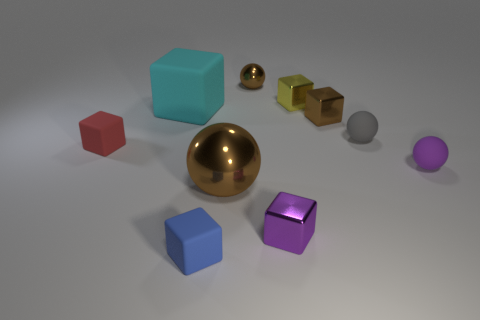Is the size of the brown shiny thing that is behind the brown cube the same as the brown block?
Provide a short and direct response. Yes. There is a tiny object that is on the left side of the cyan matte object; what is its material?
Offer a very short reply. Rubber. What number of rubber things are brown blocks or purple balls?
Your response must be concise. 1. Are there fewer gray spheres to the left of the tiny gray thing than big brown cubes?
Offer a terse response. No. What is the shape of the tiny brown shiny thing in front of the shiny ball behind the large matte cube that is in front of the small metal ball?
Keep it short and to the point. Cube. Is the large shiny ball the same color as the tiny shiny ball?
Your response must be concise. Yes. Is the number of large green cylinders greater than the number of small metallic things?
Give a very brief answer. No. How many other things are there of the same material as the blue object?
Ensure brevity in your answer.  4. How many things are red shiny objects or things behind the blue matte block?
Offer a terse response. 9. Is the number of gray spheres less than the number of small red metallic things?
Your answer should be compact. No. 